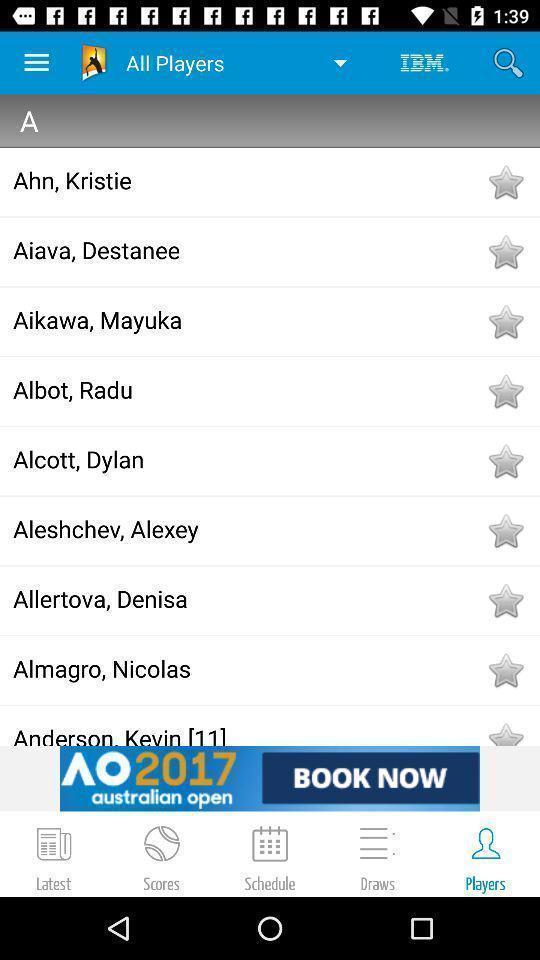What is the overall content of this screenshot? Page displaying list of players. 